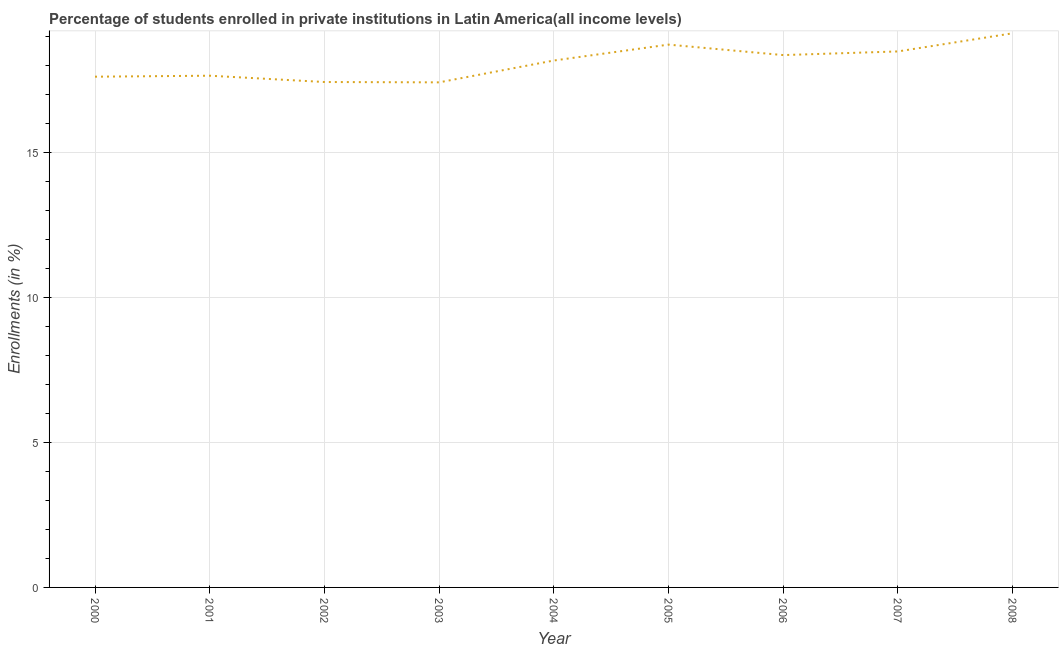What is the enrollments in private institutions in 2000?
Make the answer very short. 17.63. Across all years, what is the maximum enrollments in private institutions?
Your response must be concise. 19.13. Across all years, what is the minimum enrollments in private institutions?
Provide a short and direct response. 17.43. What is the sum of the enrollments in private institutions?
Make the answer very short. 163.08. What is the difference between the enrollments in private institutions in 2000 and 2004?
Provide a short and direct response. -0.56. What is the average enrollments in private institutions per year?
Provide a succinct answer. 18.12. What is the median enrollments in private institutions?
Offer a terse response. 18.19. Do a majority of the years between 2001 and 2000 (inclusive) have enrollments in private institutions greater than 4 %?
Offer a very short reply. No. What is the ratio of the enrollments in private institutions in 2002 to that in 2007?
Offer a terse response. 0.94. What is the difference between the highest and the second highest enrollments in private institutions?
Your answer should be very brief. 0.39. Is the sum of the enrollments in private institutions in 2002 and 2006 greater than the maximum enrollments in private institutions across all years?
Your answer should be compact. Yes. What is the difference between the highest and the lowest enrollments in private institutions?
Ensure brevity in your answer.  1.69. In how many years, is the enrollments in private institutions greater than the average enrollments in private institutions taken over all years?
Give a very brief answer. 5. How many years are there in the graph?
Your answer should be compact. 9. What is the difference between two consecutive major ticks on the Y-axis?
Your response must be concise. 5. Are the values on the major ticks of Y-axis written in scientific E-notation?
Your answer should be compact. No. Does the graph contain any zero values?
Your response must be concise. No. What is the title of the graph?
Give a very brief answer. Percentage of students enrolled in private institutions in Latin America(all income levels). What is the label or title of the Y-axis?
Your response must be concise. Enrollments (in %). What is the Enrollments (in %) of 2000?
Your answer should be very brief. 17.63. What is the Enrollments (in %) in 2001?
Offer a very short reply. 17.66. What is the Enrollments (in %) in 2002?
Provide a succinct answer. 17.44. What is the Enrollments (in %) of 2003?
Provide a succinct answer. 17.43. What is the Enrollments (in %) in 2004?
Your answer should be very brief. 18.19. What is the Enrollments (in %) of 2005?
Make the answer very short. 18.73. What is the Enrollments (in %) in 2006?
Give a very brief answer. 18.37. What is the Enrollments (in %) in 2007?
Offer a terse response. 18.5. What is the Enrollments (in %) of 2008?
Offer a terse response. 19.13. What is the difference between the Enrollments (in %) in 2000 and 2001?
Provide a succinct answer. -0.03. What is the difference between the Enrollments (in %) in 2000 and 2002?
Your answer should be very brief. 0.18. What is the difference between the Enrollments (in %) in 2000 and 2003?
Your response must be concise. 0.2. What is the difference between the Enrollments (in %) in 2000 and 2004?
Offer a terse response. -0.56. What is the difference between the Enrollments (in %) in 2000 and 2005?
Offer a very short reply. -1.11. What is the difference between the Enrollments (in %) in 2000 and 2006?
Keep it short and to the point. -0.75. What is the difference between the Enrollments (in %) in 2000 and 2007?
Provide a short and direct response. -0.87. What is the difference between the Enrollments (in %) in 2000 and 2008?
Offer a terse response. -1.5. What is the difference between the Enrollments (in %) in 2001 and 2002?
Offer a terse response. 0.22. What is the difference between the Enrollments (in %) in 2001 and 2003?
Give a very brief answer. 0.23. What is the difference between the Enrollments (in %) in 2001 and 2004?
Keep it short and to the point. -0.52. What is the difference between the Enrollments (in %) in 2001 and 2005?
Make the answer very short. -1.07. What is the difference between the Enrollments (in %) in 2001 and 2006?
Your response must be concise. -0.71. What is the difference between the Enrollments (in %) in 2001 and 2007?
Make the answer very short. -0.84. What is the difference between the Enrollments (in %) in 2001 and 2008?
Provide a succinct answer. -1.46. What is the difference between the Enrollments (in %) in 2002 and 2003?
Your response must be concise. 0.01. What is the difference between the Enrollments (in %) in 2002 and 2004?
Provide a short and direct response. -0.74. What is the difference between the Enrollments (in %) in 2002 and 2005?
Provide a succinct answer. -1.29. What is the difference between the Enrollments (in %) in 2002 and 2006?
Offer a terse response. -0.93. What is the difference between the Enrollments (in %) in 2002 and 2007?
Provide a succinct answer. -1.06. What is the difference between the Enrollments (in %) in 2002 and 2008?
Offer a terse response. -1.68. What is the difference between the Enrollments (in %) in 2003 and 2004?
Offer a very short reply. -0.75. What is the difference between the Enrollments (in %) in 2003 and 2005?
Your response must be concise. -1.3. What is the difference between the Enrollments (in %) in 2003 and 2006?
Provide a short and direct response. -0.94. What is the difference between the Enrollments (in %) in 2003 and 2007?
Make the answer very short. -1.07. What is the difference between the Enrollments (in %) in 2003 and 2008?
Your answer should be compact. -1.69. What is the difference between the Enrollments (in %) in 2004 and 2005?
Give a very brief answer. -0.55. What is the difference between the Enrollments (in %) in 2004 and 2006?
Your answer should be compact. -0.19. What is the difference between the Enrollments (in %) in 2004 and 2007?
Offer a very short reply. -0.31. What is the difference between the Enrollments (in %) in 2004 and 2008?
Provide a succinct answer. -0.94. What is the difference between the Enrollments (in %) in 2005 and 2006?
Provide a succinct answer. 0.36. What is the difference between the Enrollments (in %) in 2005 and 2007?
Your answer should be compact. 0.24. What is the difference between the Enrollments (in %) in 2005 and 2008?
Ensure brevity in your answer.  -0.39. What is the difference between the Enrollments (in %) in 2006 and 2007?
Provide a short and direct response. -0.13. What is the difference between the Enrollments (in %) in 2006 and 2008?
Make the answer very short. -0.75. What is the difference between the Enrollments (in %) in 2007 and 2008?
Your answer should be compact. -0.63. What is the ratio of the Enrollments (in %) in 2000 to that in 2002?
Your answer should be compact. 1.01. What is the ratio of the Enrollments (in %) in 2000 to that in 2003?
Offer a terse response. 1.01. What is the ratio of the Enrollments (in %) in 2000 to that in 2005?
Give a very brief answer. 0.94. What is the ratio of the Enrollments (in %) in 2000 to that in 2006?
Offer a very short reply. 0.96. What is the ratio of the Enrollments (in %) in 2000 to that in 2007?
Your response must be concise. 0.95. What is the ratio of the Enrollments (in %) in 2000 to that in 2008?
Ensure brevity in your answer.  0.92. What is the ratio of the Enrollments (in %) in 2001 to that in 2002?
Your response must be concise. 1.01. What is the ratio of the Enrollments (in %) in 2001 to that in 2003?
Keep it short and to the point. 1.01. What is the ratio of the Enrollments (in %) in 2001 to that in 2004?
Provide a short and direct response. 0.97. What is the ratio of the Enrollments (in %) in 2001 to that in 2005?
Your answer should be compact. 0.94. What is the ratio of the Enrollments (in %) in 2001 to that in 2006?
Provide a succinct answer. 0.96. What is the ratio of the Enrollments (in %) in 2001 to that in 2007?
Your response must be concise. 0.95. What is the ratio of the Enrollments (in %) in 2001 to that in 2008?
Your answer should be compact. 0.92. What is the ratio of the Enrollments (in %) in 2002 to that in 2003?
Your answer should be very brief. 1. What is the ratio of the Enrollments (in %) in 2002 to that in 2006?
Your response must be concise. 0.95. What is the ratio of the Enrollments (in %) in 2002 to that in 2007?
Give a very brief answer. 0.94. What is the ratio of the Enrollments (in %) in 2002 to that in 2008?
Your answer should be very brief. 0.91. What is the ratio of the Enrollments (in %) in 2003 to that in 2006?
Give a very brief answer. 0.95. What is the ratio of the Enrollments (in %) in 2003 to that in 2007?
Make the answer very short. 0.94. What is the ratio of the Enrollments (in %) in 2003 to that in 2008?
Make the answer very short. 0.91. What is the ratio of the Enrollments (in %) in 2004 to that in 2005?
Offer a terse response. 0.97. What is the ratio of the Enrollments (in %) in 2004 to that in 2006?
Provide a short and direct response. 0.99. What is the ratio of the Enrollments (in %) in 2004 to that in 2008?
Make the answer very short. 0.95. What is the ratio of the Enrollments (in %) in 2005 to that in 2006?
Your answer should be very brief. 1.02. What is the ratio of the Enrollments (in %) in 2005 to that in 2008?
Ensure brevity in your answer.  0.98. What is the ratio of the Enrollments (in %) in 2007 to that in 2008?
Provide a succinct answer. 0.97. 